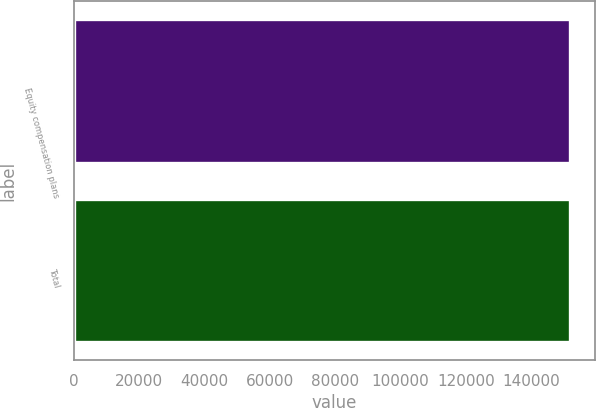Convert chart. <chart><loc_0><loc_0><loc_500><loc_500><bar_chart><fcel>Equity compensation plans<fcel>Total<nl><fcel>151945<fcel>151945<nl></chart> 